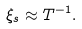Convert formula to latex. <formula><loc_0><loc_0><loc_500><loc_500>\xi _ { s } \approx T ^ { - 1 } .</formula> 